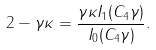Convert formula to latex. <formula><loc_0><loc_0><loc_500><loc_500>2 - \gamma \kappa = \frac { \gamma \kappa I _ { 1 } ( C _ { 4 } \gamma ) } { I _ { 0 } ( C _ { 4 } \gamma ) } .</formula> 